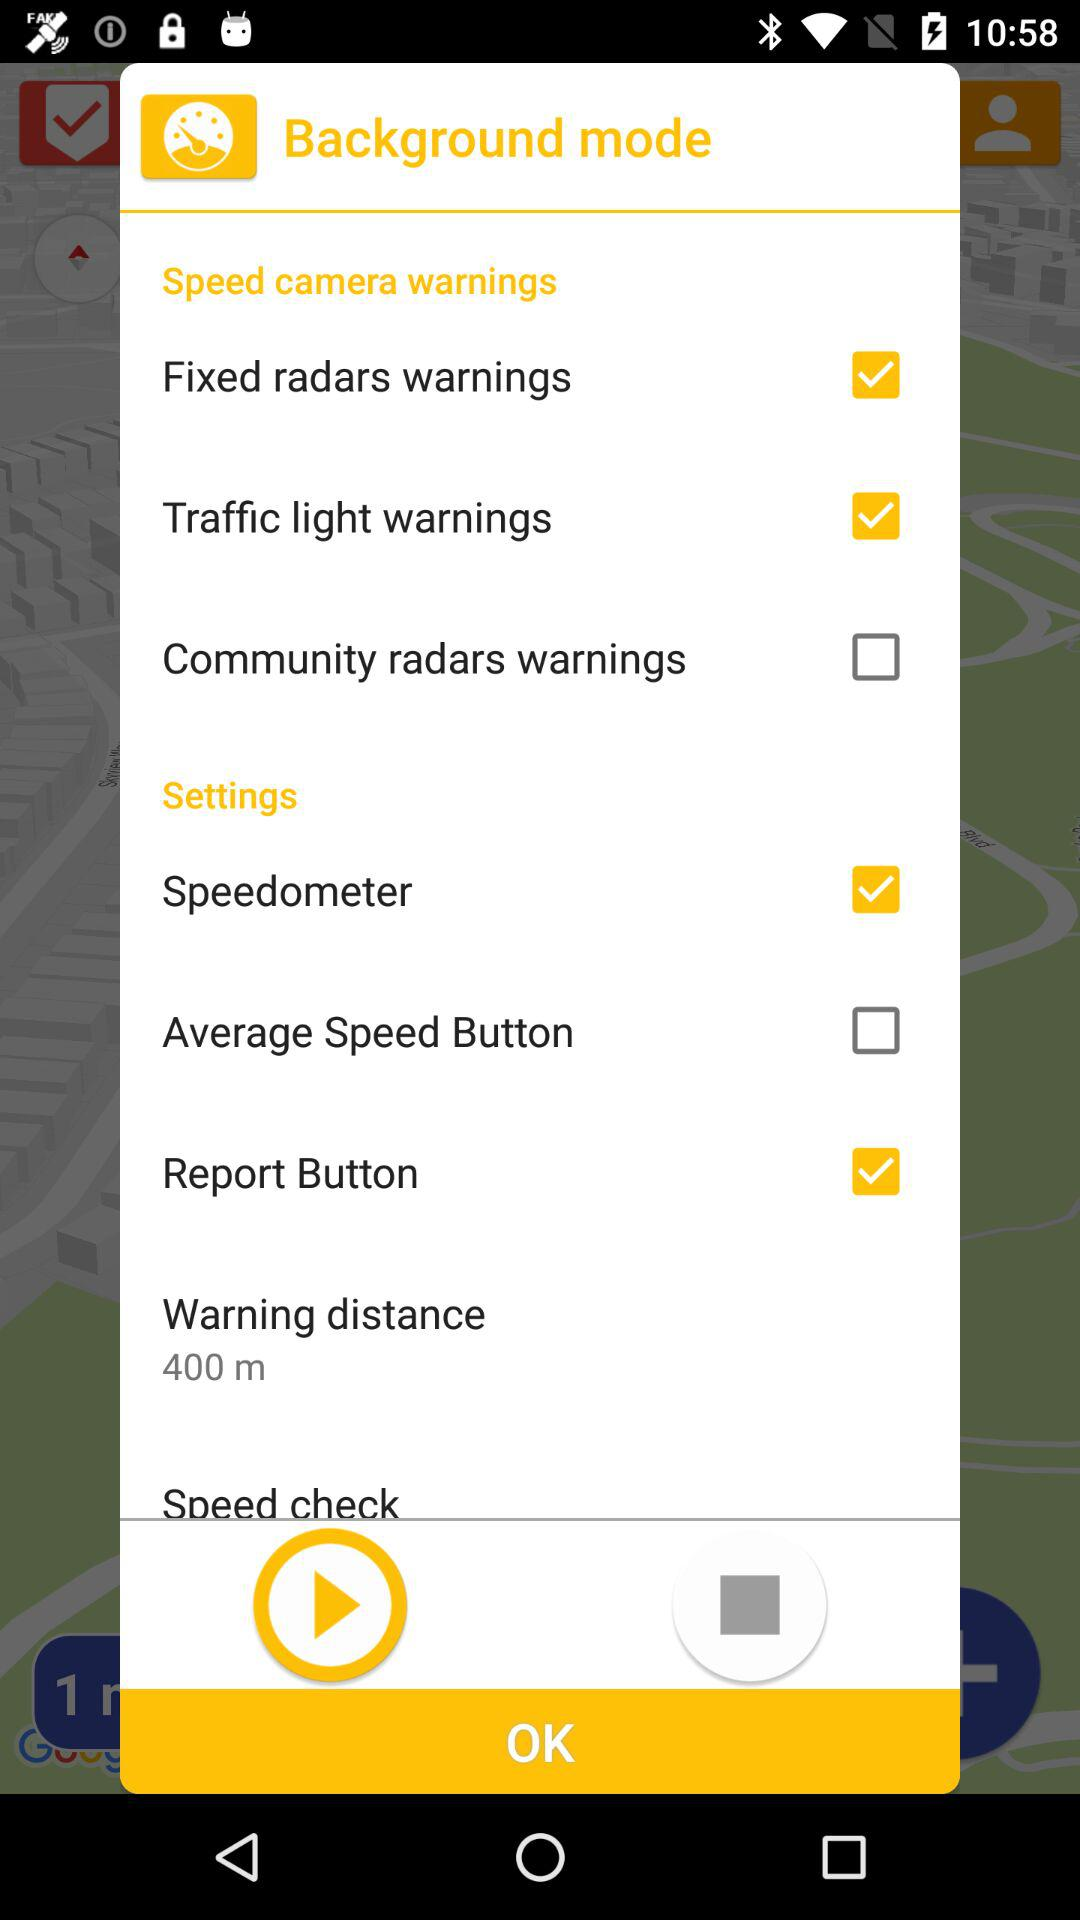Which options are selected in "Speed camera warnings"? The selected options are "Fixed radars warnings" and "Traffic light warnings". 